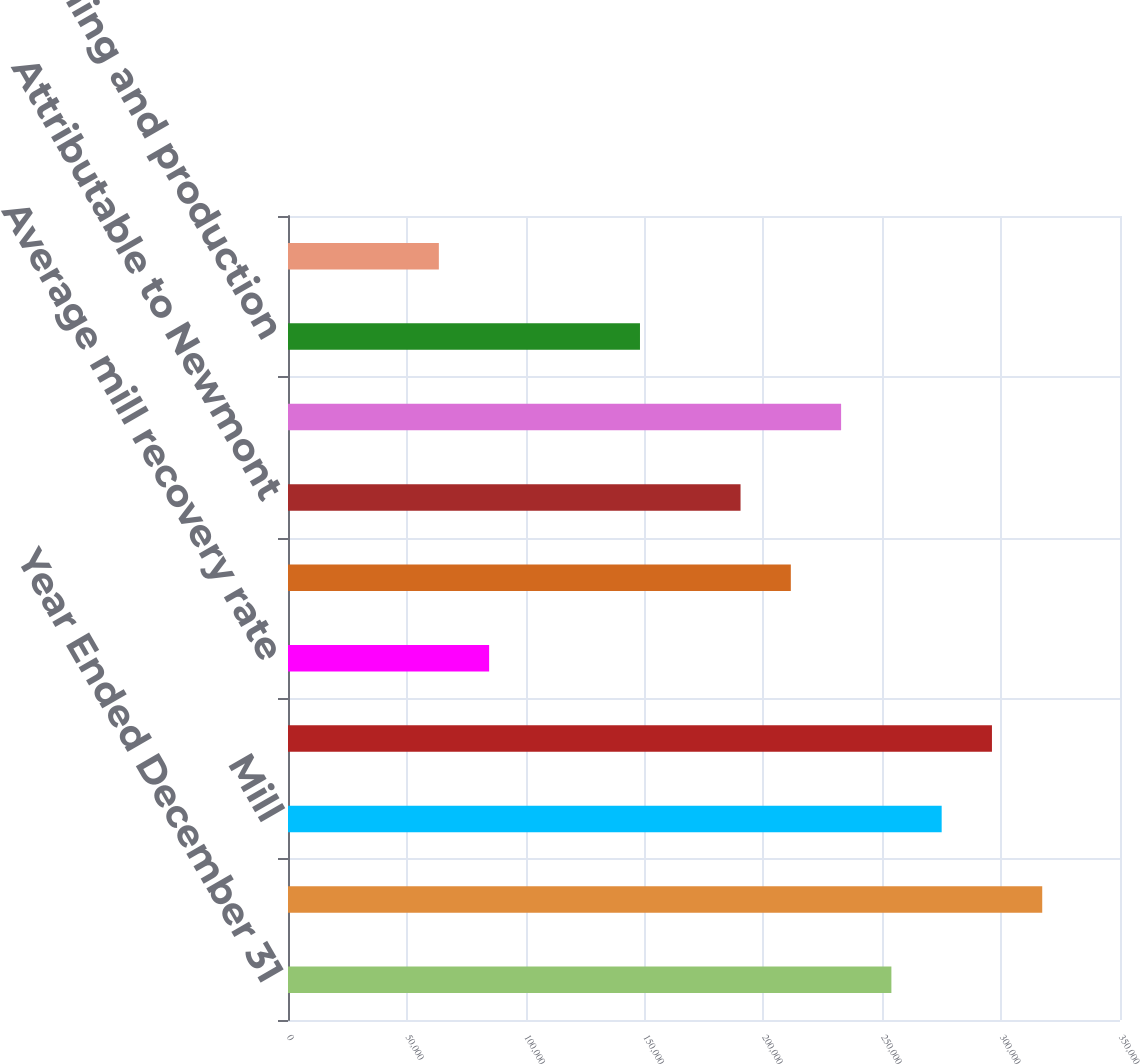Convert chart. <chart><loc_0><loc_0><loc_500><loc_500><bar_chart><fcel>Year Ended December 31<fcel>Open pit<fcel>Mill<fcel>Leach<fcel>Average mill recovery rate<fcel>Consolidated<fcel>Attributable to Newmont<fcel>Consolidated ounces sold (000)<fcel>Direct mining and production<fcel>By-product credits<nl><fcel>253829<fcel>317286<fcel>274982<fcel>296134<fcel>84611.8<fcel>211525<fcel>190373<fcel>232677<fcel>148068<fcel>63459.6<nl></chart> 